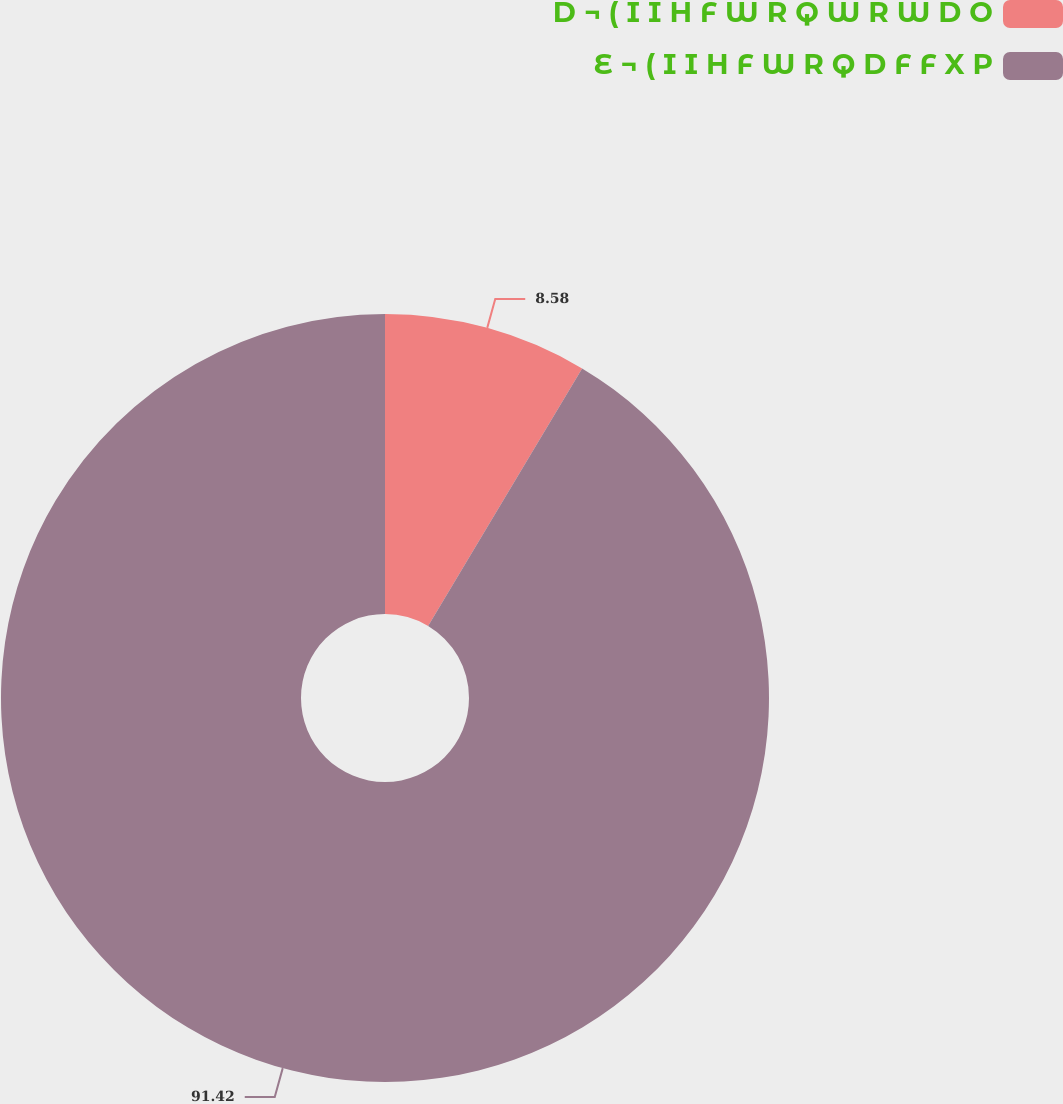<chart> <loc_0><loc_0><loc_500><loc_500><pie_chart><fcel>D ¬ ( I I H F W R Q W R W D O<fcel>E ¬ ( I I H F W R Q D F F X P<nl><fcel>8.58%<fcel>91.42%<nl></chart> 